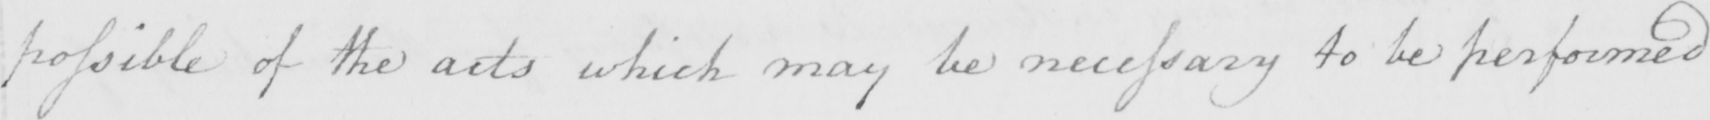What text is written in this handwritten line? possible of the acts which may be necessary to be performed 